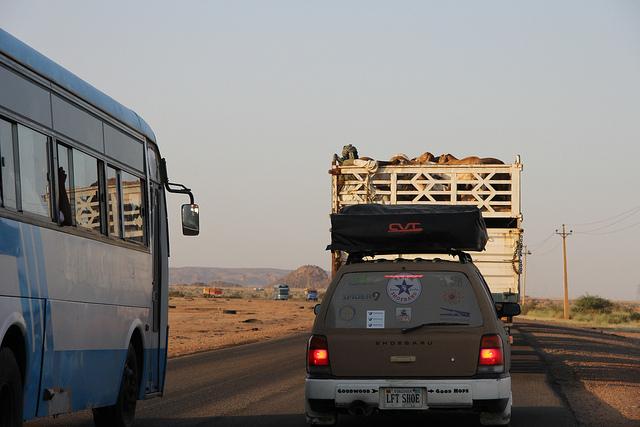Why is this truck stopped?
Be succinct. Traffic. Is the sun setting?
Be succinct. Yes. Is it approximately noon?
Write a very short answer. No. What is the oversized truck carrying?
Concise answer only. Animals. What is on top of the truck?
Quick response, please. Cows. Where is the buses at?
Answer briefly. Road. Is there an advertisement on the bus?
Keep it brief. No. What color is the bus on the left?
Keep it brief. Blue and white. Where is the bus parked?
Concise answer only. Street. What letters are on the black case on top of the car?
Be succinct. Cvt. 